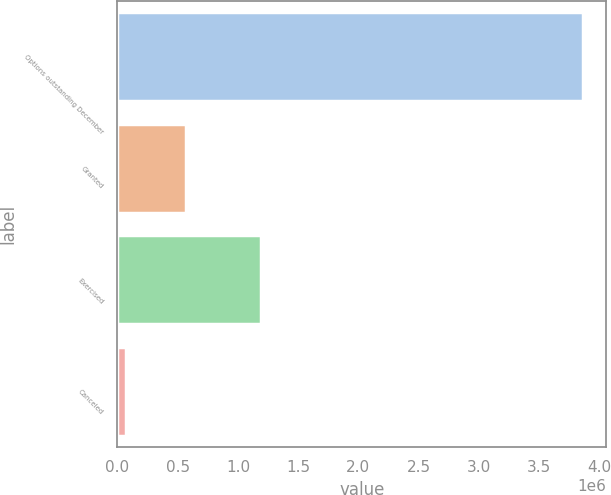Convert chart to OTSL. <chart><loc_0><loc_0><loc_500><loc_500><bar_chart><fcel>Options outstanding December<fcel>Granted<fcel>Exercised<fcel>Canceled<nl><fcel>3.86217e+06<fcel>571087<fcel>1.18832e+06<fcel>73592<nl></chart> 